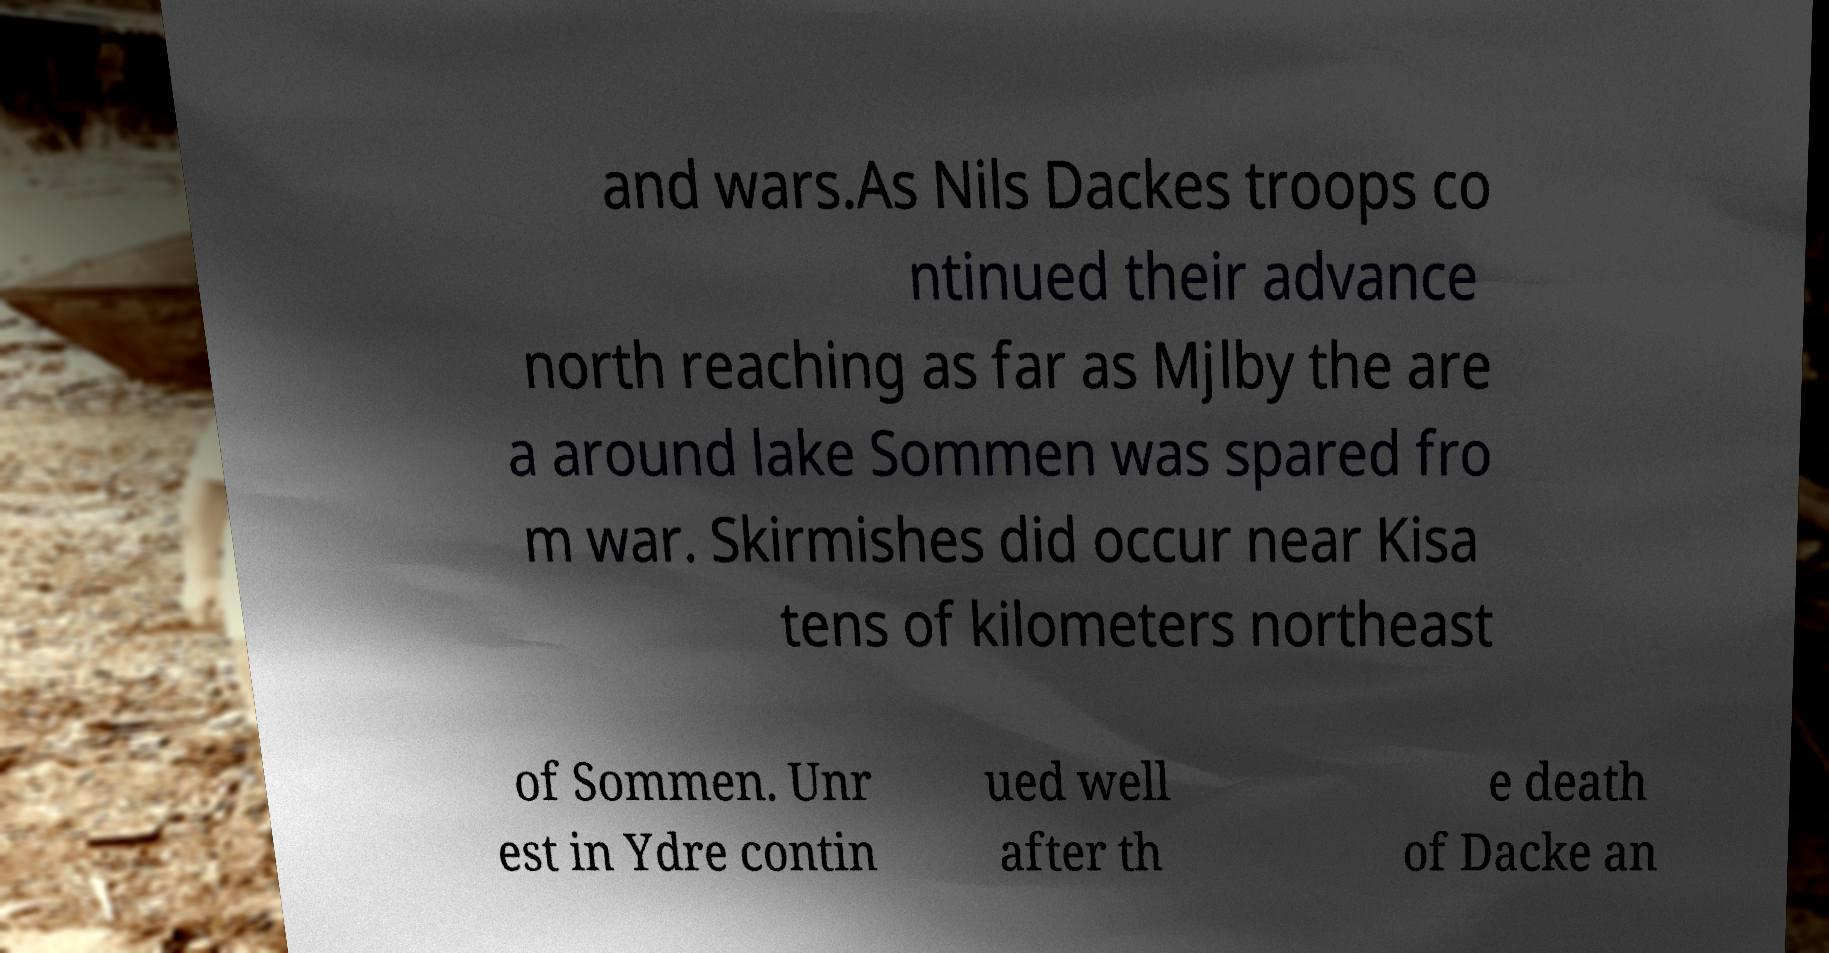What messages or text are displayed in this image? I need them in a readable, typed format. and wars.As Nils Dackes troops co ntinued their advance north reaching as far as Mjlby the are a around lake Sommen was spared fro m war. Skirmishes did occur near Kisa tens of kilometers northeast of Sommen. Unr est in Ydre contin ued well after th e death of Dacke an 